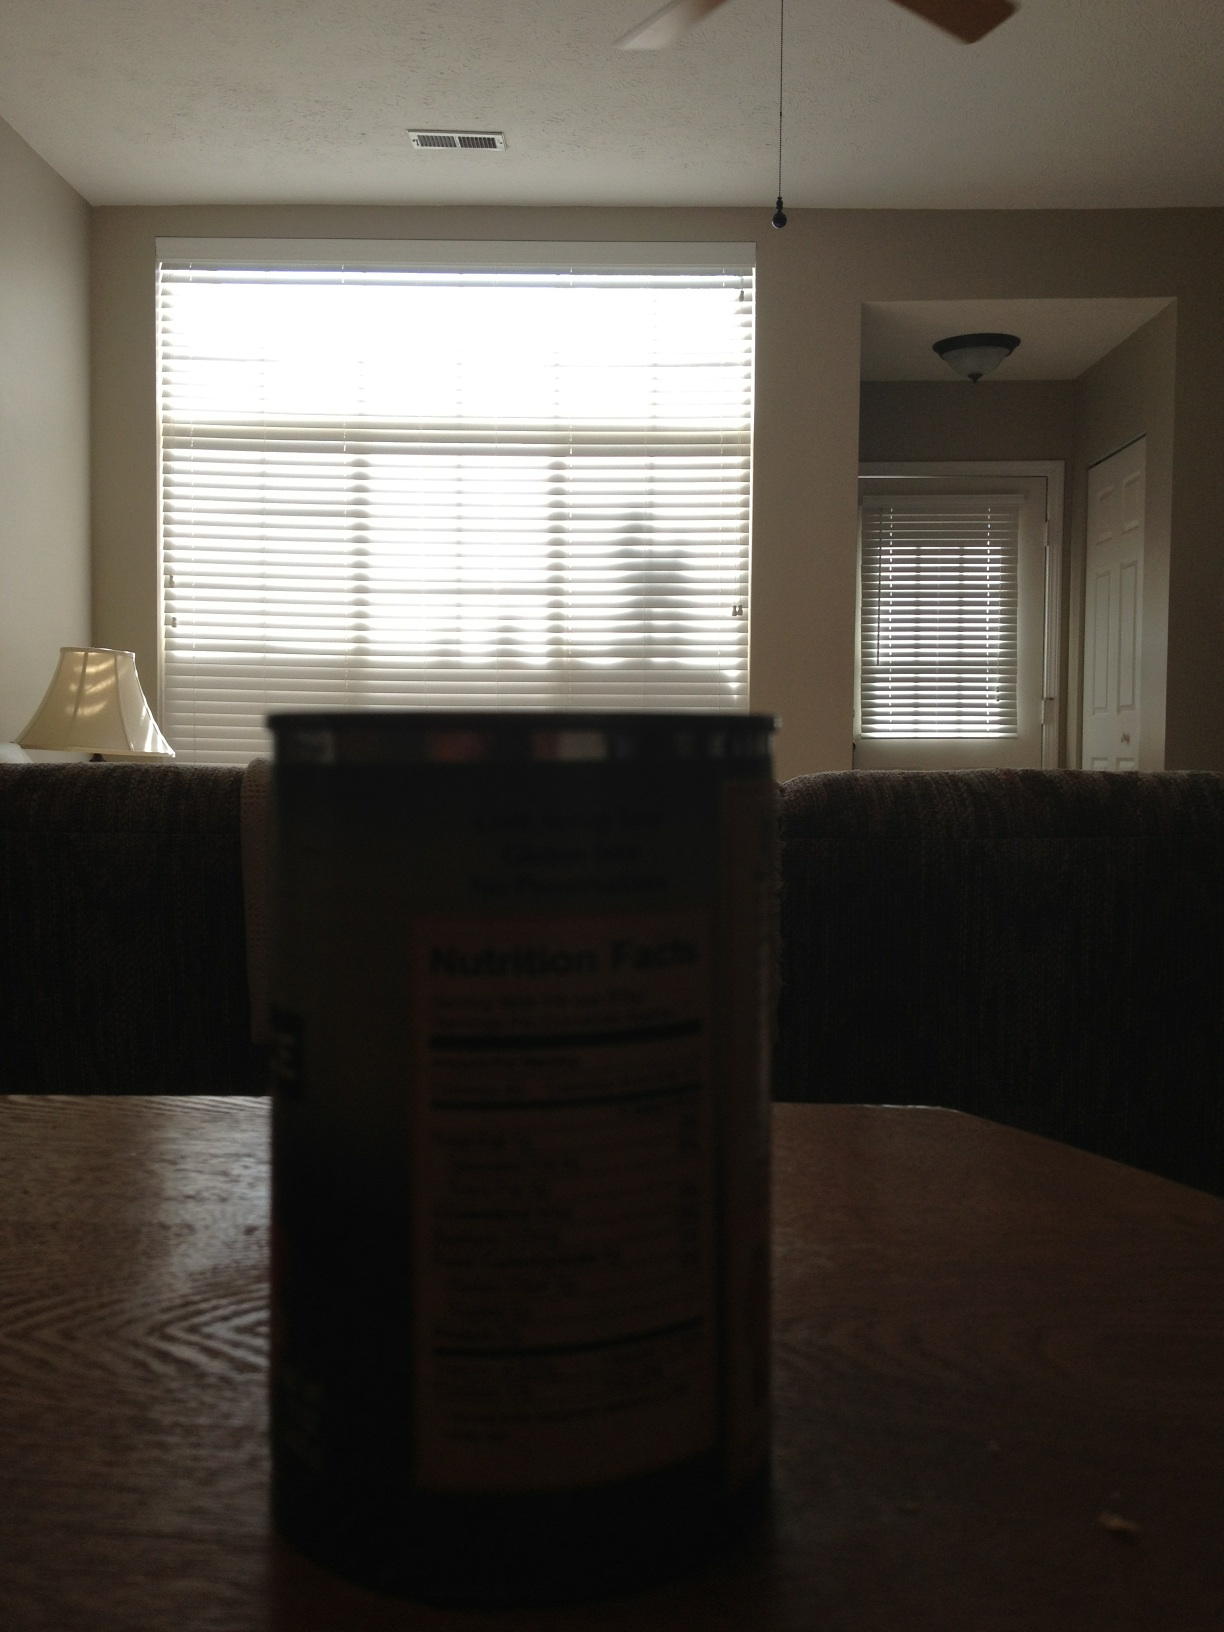What kind of tomatoes are these? The question appears to be about identifying a type of tomato in the image. However, due to the low lighting and the focus of the can, it is not possible to accurately determine the type of tomatoes. 